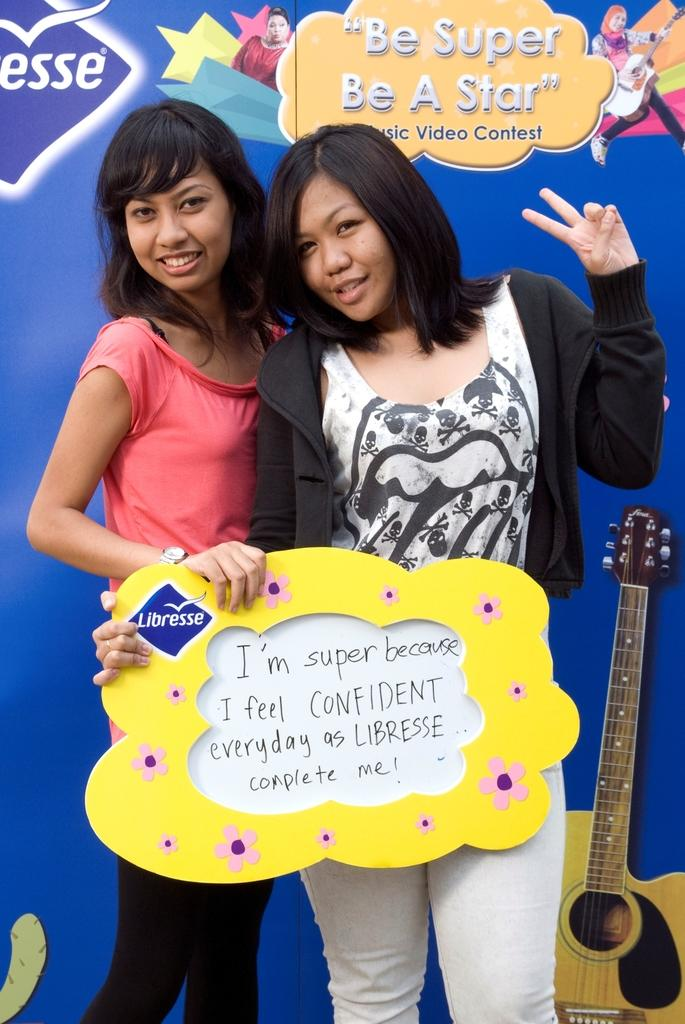What message is displayed on the banner in the background? The banner in the background has the text "be super be a star". How many people are in the image? There are two women in the image. What are the women holding in their hands? The women are holding a board in their hands. What are the women doing in the image? The women are posing for a still by looking at the camera. What type of vegetable is the women using as a hat in the image? There is no vegetable or hat present in the image; the women are holding a board and posing for a still. 